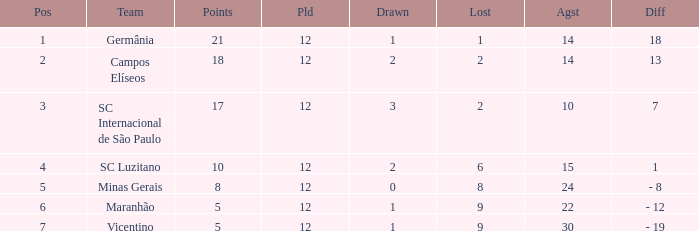What is the sum of drawn that has a played more than 12? 0.0. 